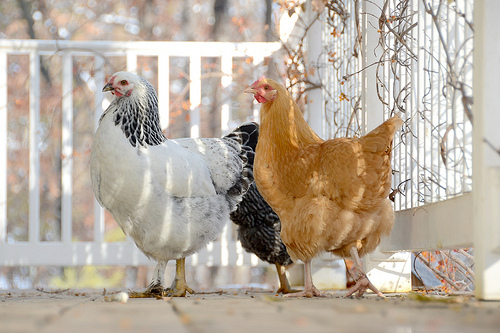<image>
Can you confirm if the hen is to the left of the hen? No. The hen is not to the left of the hen. From this viewpoint, they have a different horizontal relationship. Where is the chicken in relation to the fence? Is it behind the fence? No. The chicken is not behind the fence. From this viewpoint, the chicken appears to be positioned elsewhere in the scene. 